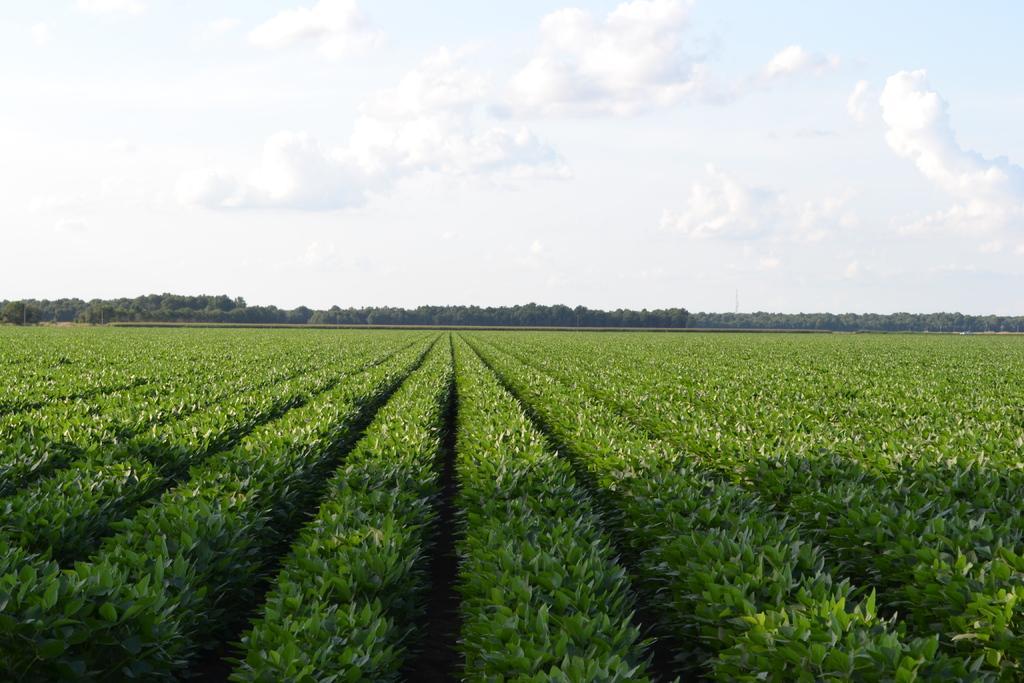How would you summarize this image in a sentence or two? In this image we can see some farmlands and in the background of the image there are some trees and sunny sky. 